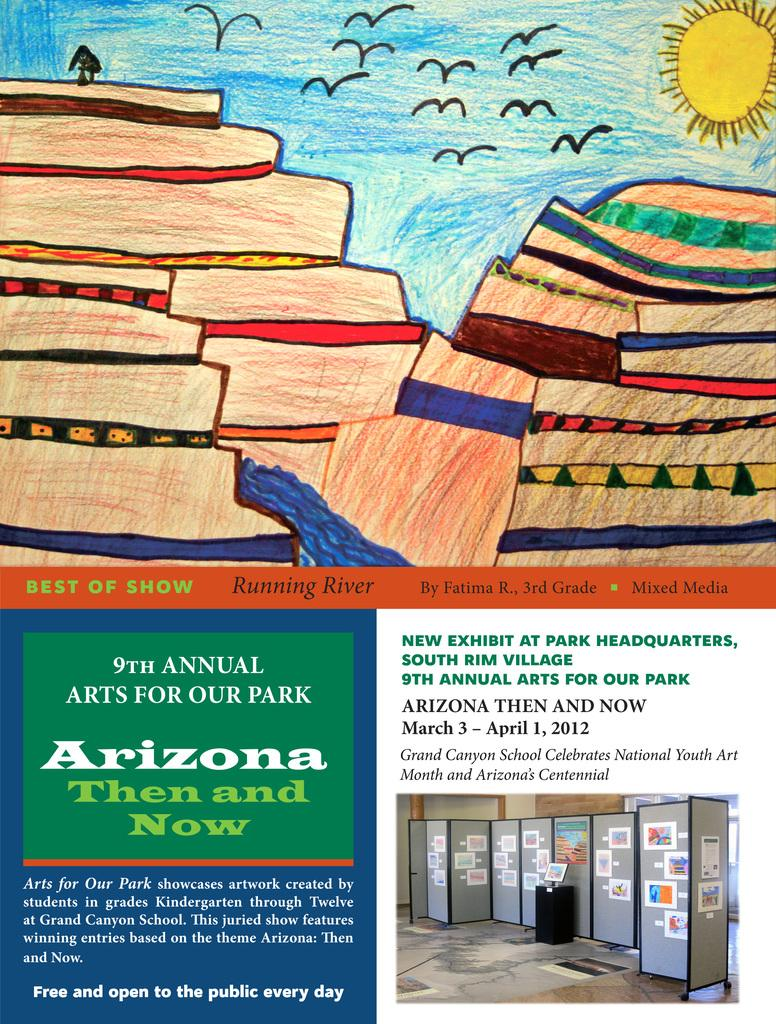<image>
Relay a brief, clear account of the picture shown. A poster with a drawing on it advertising ninth in your arts for our Park Arizona then and now. 